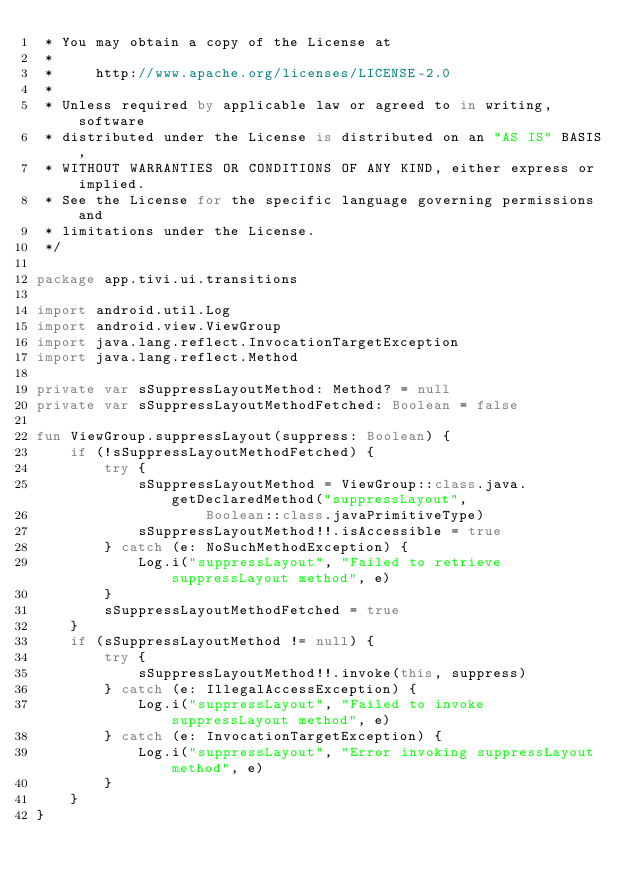<code> <loc_0><loc_0><loc_500><loc_500><_Kotlin_> * You may obtain a copy of the License at
 *
 *     http://www.apache.org/licenses/LICENSE-2.0
 *
 * Unless required by applicable law or agreed to in writing, software
 * distributed under the License is distributed on an "AS IS" BASIS,
 * WITHOUT WARRANTIES OR CONDITIONS OF ANY KIND, either express or implied.
 * See the License for the specific language governing permissions and
 * limitations under the License.
 */

package app.tivi.ui.transitions

import android.util.Log
import android.view.ViewGroup
import java.lang.reflect.InvocationTargetException
import java.lang.reflect.Method

private var sSuppressLayoutMethod: Method? = null
private var sSuppressLayoutMethodFetched: Boolean = false

fun ViewGroup.suppressLayout(suppress: Boolean) {
    if (!sSuppressLayoutMethodFetched) {
        try {
            sSuppressLayoutMethod = ViewGroup::class.java.getDeclaredMethod("suppressLayout",
                    Boolean::class.javaPrimitiveType)
            sSuppressLayoutMethod!!.isAccessible = true
        } catch (e: NoSuchMethodException) {
            Log.i("suppressLayout", "Failed to retrieve suppressLayout method", e)
        }
        sSuppressLayoutMethodFetched = true
    }
    if (sSuppressLayoutMethod != null) {
        try {
            sSuppressLayoutMethod!!.invoke(this, suppress)
        } catch (e: IllegalAccessException) {
            Log.i("suppressLayout", "Failed to invoke suppressLayout method", e)
        } catch (e: InvocationTargetException) {
            Log.i("suppressLayout", "Error invoking suppressLayout method", e)
        }
    }
}
</code> 